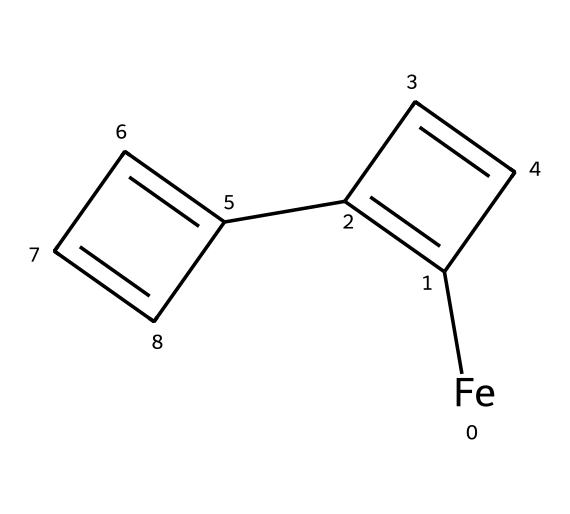What is the central metal in ferrocene? The chemical structure given shows an iron atom (Fe) at the center, surrounded by cyclopentadienyl rings.
Answer: iron How many cyclopentadienyl rings are present in ferrocene? By examining the structure, we note that there are two distinct cyclopentadienyl rings attached to the iron atom.
Answer: two What is the total number of carbon atoms in ferrocene? Counting the carbon atoms from both cyclopentadienyl rings, there are five carbons in each ring, giving a total of ten carbon atoms.
Answer: ten What type of bonding is primarily seen in ferrocene? The structure reveals that there are coordinate covalent bonds between the iron and the cyclopentadienyl rings, which is typical for organometallic compounds.
Answer: coordinate covalent Explain how the symmetry of ferrocene contributes to its stability. The geometric arrangement of the two cyclopentadienyl rings creates a symmetric and stable structure, minimizing steric hindrance and allowing effective orbital overlap, which contributes to its stability.
Answer: minimizes steric hindrance Why might ferrocene be preferred in conservation treatments? Due to its stability, non-toxicity, and ability to form reversible interactions with various substrates, ferrocene is often chosen in conservation treatments to avoid damage to artifacts.
Answer: stability and non-toxicity What type of organometallic compound is ferrocene classified as? Given its structure involving a transition metal sandwiched between two cyclopentadienyl anions, ferrocene is categorized as a metallocene.
Answer: metallocene 